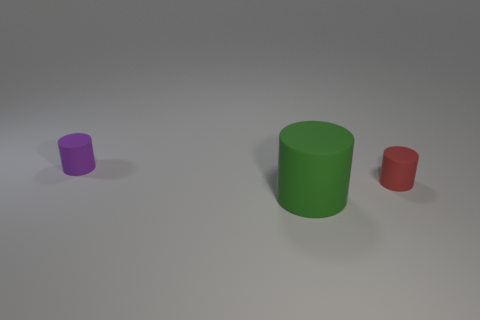Is there any other thing that is the same size as the green cylinder?
Keep it short and to the point. No. There is a red thing that is the same material as the small purple thing; what is its shape?
Provide a succinct answer. Cylinder. Do the cylinder behind the red cylinder and the green rubber thing that is on the right side of the tiny purple rubber object have the same size?
Keep it short and to the point. No. Is the number of large green rubber cylinders that are in front of the red cylinder greater than the number of purple cylinders behind the tiny purple matte cylinder?
Ensure brevity in your answer.  Yes. There is a red rubber object in front of the purple matte thing; how many large green objects are on the right side of it?
Your response must be concise. 0. Is there any other thing that is made of the same material as the purple object?
Your answer should be compact. Yes. What material is the tiny object on the right side of the rubber thing behind the tiny object that is to the right of the purple object made of?
Offer a very short reply. Rubber. What is the cylinder that is to the right of the tiny purple cylinder and behind the big green matte object made of?
Your answer should be compact. Rubber. What number of other rubber objects have the same shape as the green object?
Your answer should be very brief. 2. There is a rubber cylinder that is in front of the small red rubber cylinder that is on the right side of the big rubber cylinder; what is its size?
Offer a very short reply. Large. 